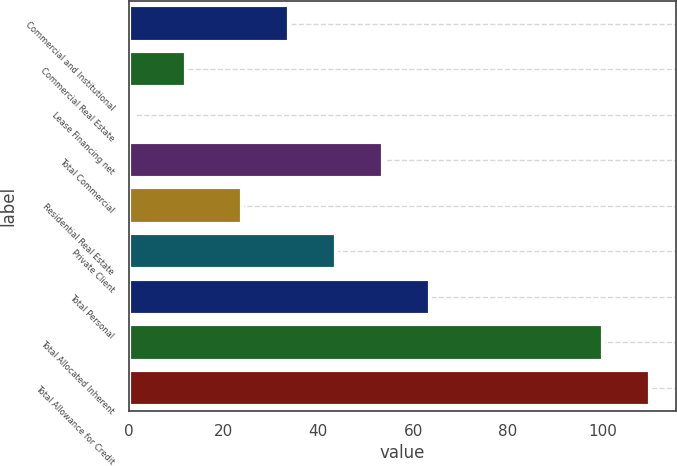Convert chart. <chart><loc_0><loc_0><loc_500><loc_500><bar_chart><fcel>Commercial and Institutional<fcel>Commercial Real Estate<fcel>Lease Financing net<fcel>Total Commercial<fcel>Residential Real Estate<fcel>Private Client<fcel>Total Personal<fcel>Total Allocated Inherent<fcel>Total Allowance for Credit<nl><fcel>33.9<fcel>12<fcel>1<fcel>53.7<fcel>24<fcel>43.8<fcel>63.6<fcel>100<fcel>109.9<nl></chart> 